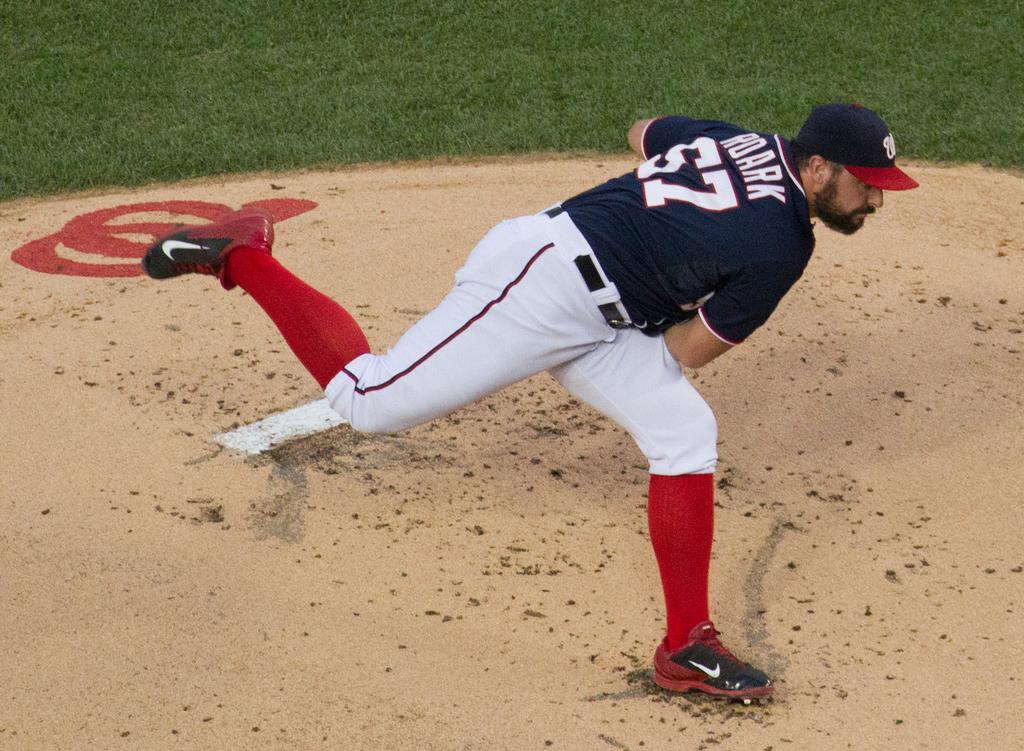<image>
Write a terse but informative summary of the picture. A pitcher that has the name Roark and the number 57 on his shirt. 